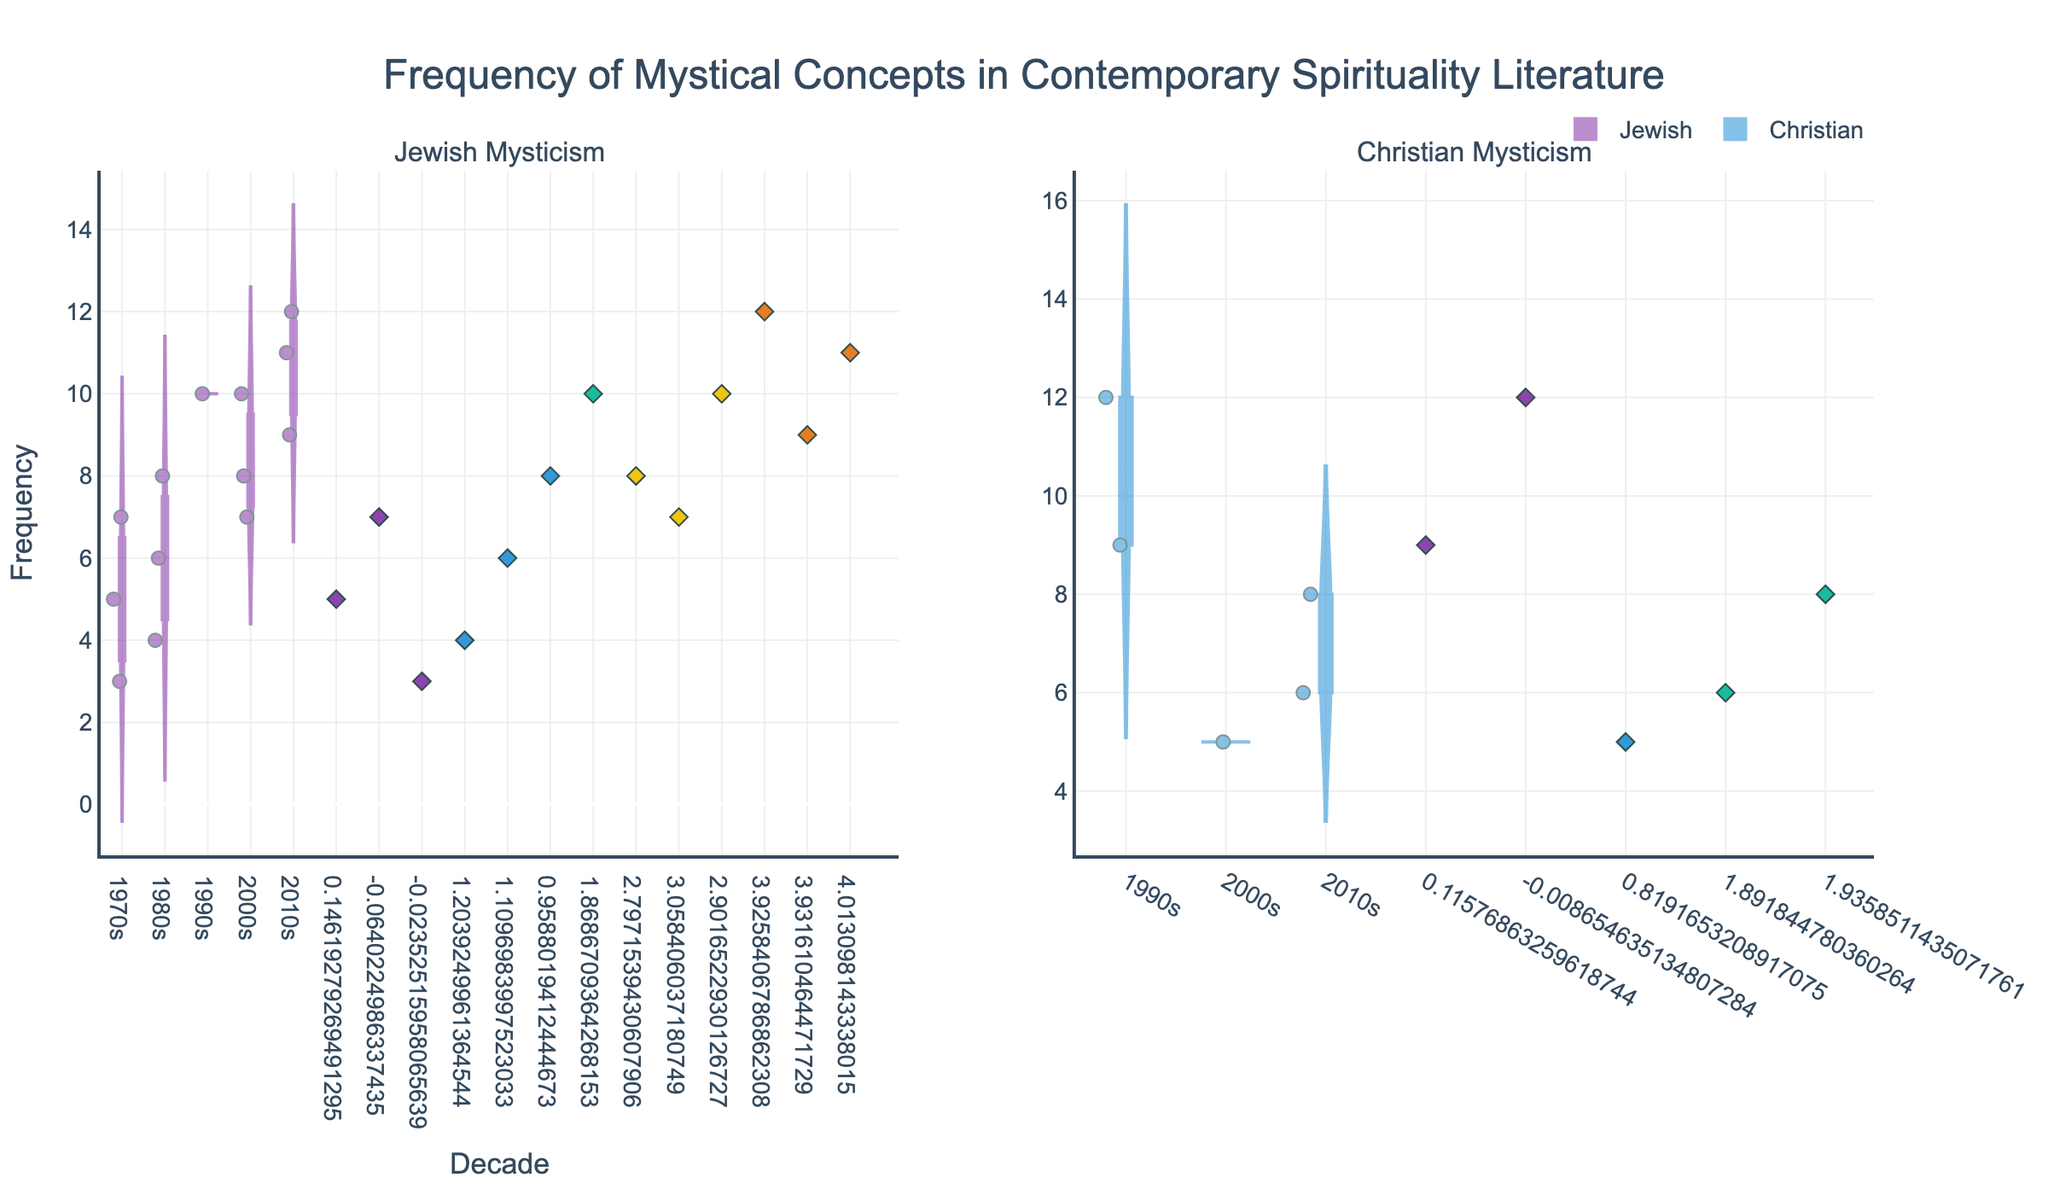Which mystical concept related to Jewish mysticism has the highest frequency mention in the 2010s? To find the answer, look at the violin plot for Jewish Mysticism in the 2010s. Notice the highest frequency mentions, which are for "Kabbalah" (12) and "Shekinah" (11). Among these, "Kabbalah" has the highest frequency.
Answer: Kabbalah What is the average frequency of mentions for mystic concepts related to Christian mysticism in the 2000s? For the 2000s under Christian mysticism, there is only one data point: "Theosis" with a frequency of 5. Therefore, the average is just the frequency of that single point.
Answer: 5 Compare the frequency of mentions of "Shekinah" in the 1990s and 2000s. Which one is higher? Look at the violin plots for "Shekinah" in the 1990s and 2000s under Jewish Mysticism. In the 1990s, the frequency is 10, and in the 2000s, it's also 10. Thus, they are equal.
Answer: Equal What is the range of the frequency of mentions for "En-Sof" in the 2010s? Check the violin plot for Jewish Mysticism in the 2010s. The range is calculated as the difference between the highest and lowest points for "En-Sof". The highest is 9, and the lowest is also 9. Hence, the range is 0.
Answer: 0 In which decade did "Hesychasm" appear, and what was its frequency? Observe the violin plot for Christian Mysticism. "Hesychasm" appears only in the 2010s with a frequency of 6.
Answer: 2010s, 6 What is the most common frequency of mentions (mode) for "Shekinah" across all decades? For the violin plots under Jewish Mysticism, inspect the "Shekinah" data across all decades. The frequencies are 7 for the 1970s, 10 for the 1990s, 10 for the 2000s, and 11 for the 2010s. The most common frequency is 10, which appears twice.
Answer: 10 How does the frequency of mentions of "Gnosis" in the 1990s compare to "Theosis" in the 2010s? Check the violin plots for Christian Mysticism. "Gnosis" in the 1990s has a frequency of 12, while "Theosis" in the 2010s has a frequency of 8. Hence, "Gnosis" has a higher frequency.
Answer: Gnosis is higher In the 2000s, how many mystic traditions have the same number of total mentions? Summing the frequency for each tradition in the 2000s, Jewish mysticism has "Sefirot" (8), "En-Sof" (7), and "Shekinah" (10), summing to 25. Christian mysticism only has "Theosis" with a frequency of 5. Therefore, only Jewish mysticism (total 25) appears, making it one tradition.
Answer: 1 What is the frequency difference between "Kabbalah" mentions in the 1980s and 2010s? Check the violin plots for Jewish Mysticism. "Kabbalah" in the 1980s has a frequency of 8, and in the 2010s, it's 12. The difference is 12 - 8 = 4.
Answer: 4 